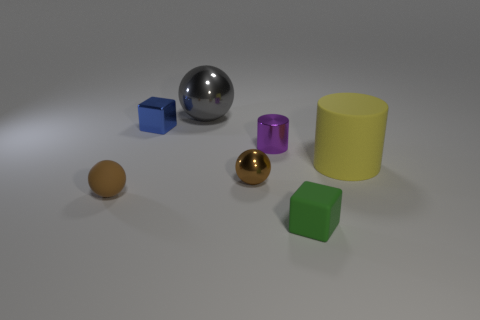Are there an equal number of small metal cylinders in front of the tiny rubber sphere and large purple metallic cylinders?
Make the answer very short. Yes. There is a object that is to the left of the tiny block on the left side of the metal thing that is on the right side of the small shiny sphere; what is it made of?
Your answer should be very brief. Rubber. Are there any yellow rubber cylinders that have the same size as the matte block?
Offer a very short reply. No. What shape is the yellow object?
Your answer should be compact. Cylinder. How many balls are either gray things or purple objects?
Your response must be concise. 1. Are there an equal number of yellow rubber cylinders that are on the left side of the gray thing and objects behind the small brown matte sphere?
Keep it short and to the point. No. There is a small brown object that is to the right of the sphere behind the large matte cylinder; how many big yellow rubber cylinders are on the left side of it?
Ensure brevity in your answer.  0. There is a small object that is the same color as the tiny matte ball; what shape is it?
Your answer should be compact. Sphere. There is a small rubber ball; is its color the same as the metal thing that is in front of the purple metallic cylinder?
Provide a short and direct response. Yes. Is the number of tiny shiny things that are in front of the small blue thing greater than the number of small yellow cylinders?
Provide a short and direct response. Yes. 